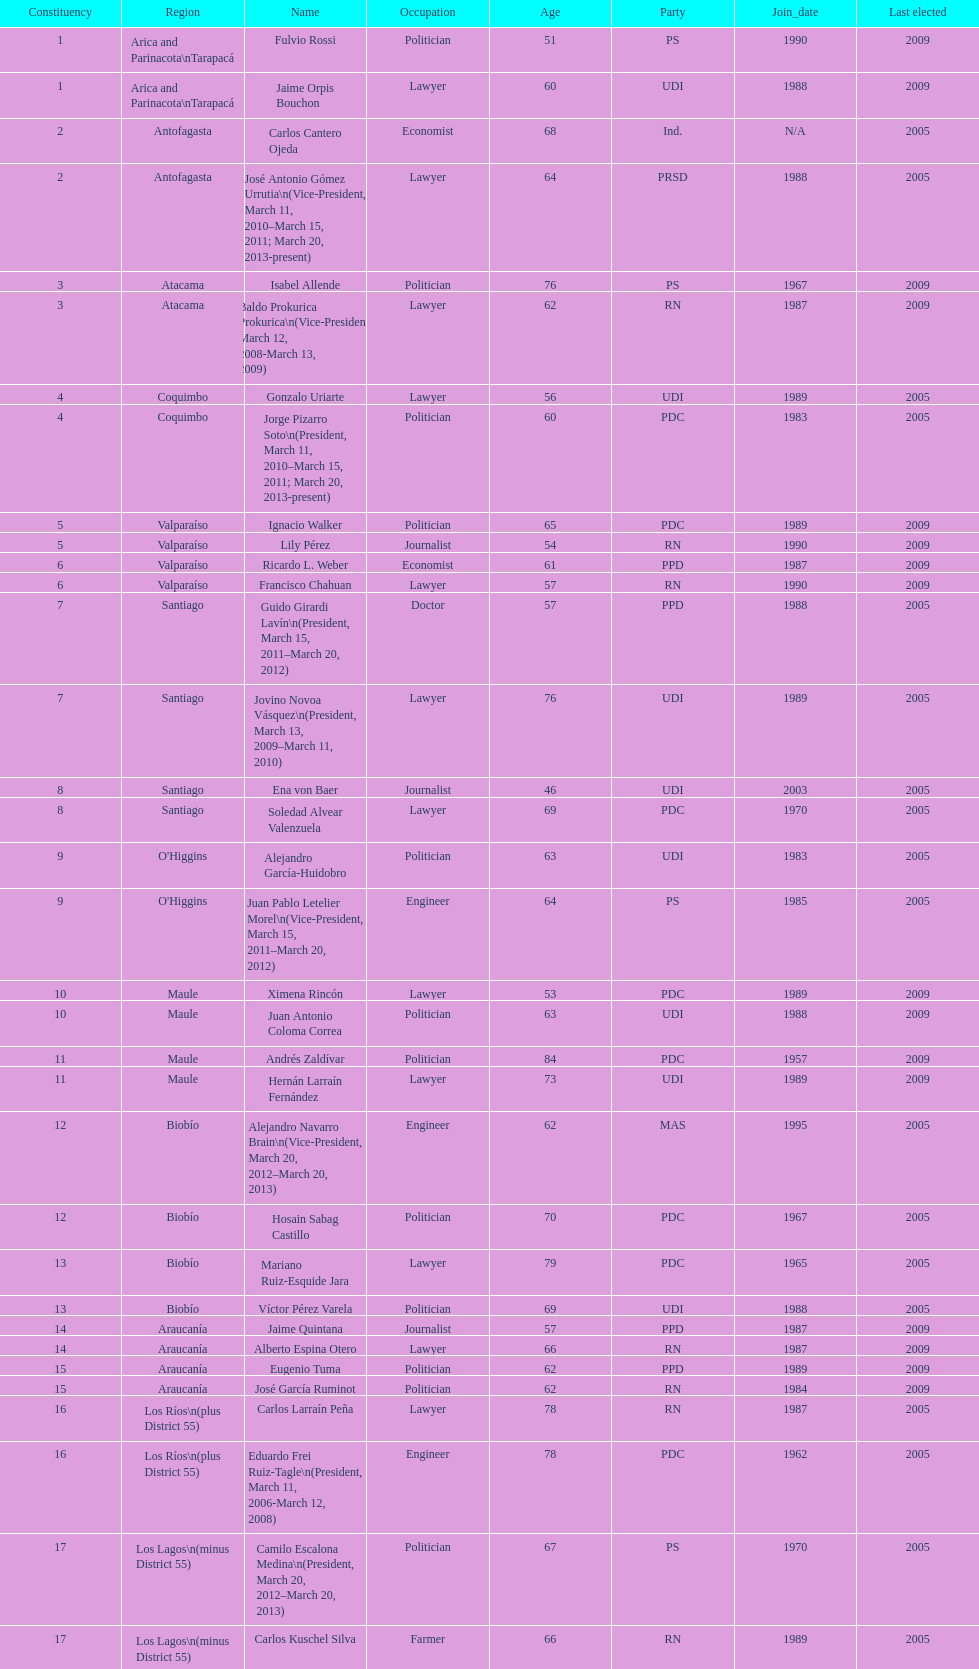What is the last region listed on the table? Magallanes. 